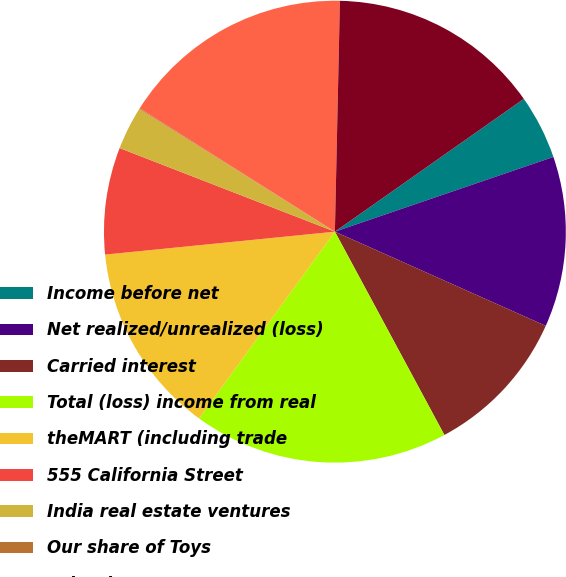<chart> <loc_0><loc_0><loc_500><loc_500><pie_chart><fcel>Income before net<fcel>Net realized/unrealized (loss)<fcel>Carried interest<fcel>Total (loss) income from real<fcel>theMART (including trade<fcel>555 California Street<fcel>India real estate ventures<fcel>Our share of Toys<fcel>Other investments<fcel>Corporate general and<nl><fcel>4.51%<fcel>11.93%<fcel>10.45%<fcel>17.87%<fcel>13.41%<fcel>7.48%<fcel>3.02%<fcel>0.05%<fcel>16.38%<fcel>14.9%<nl></chart> 